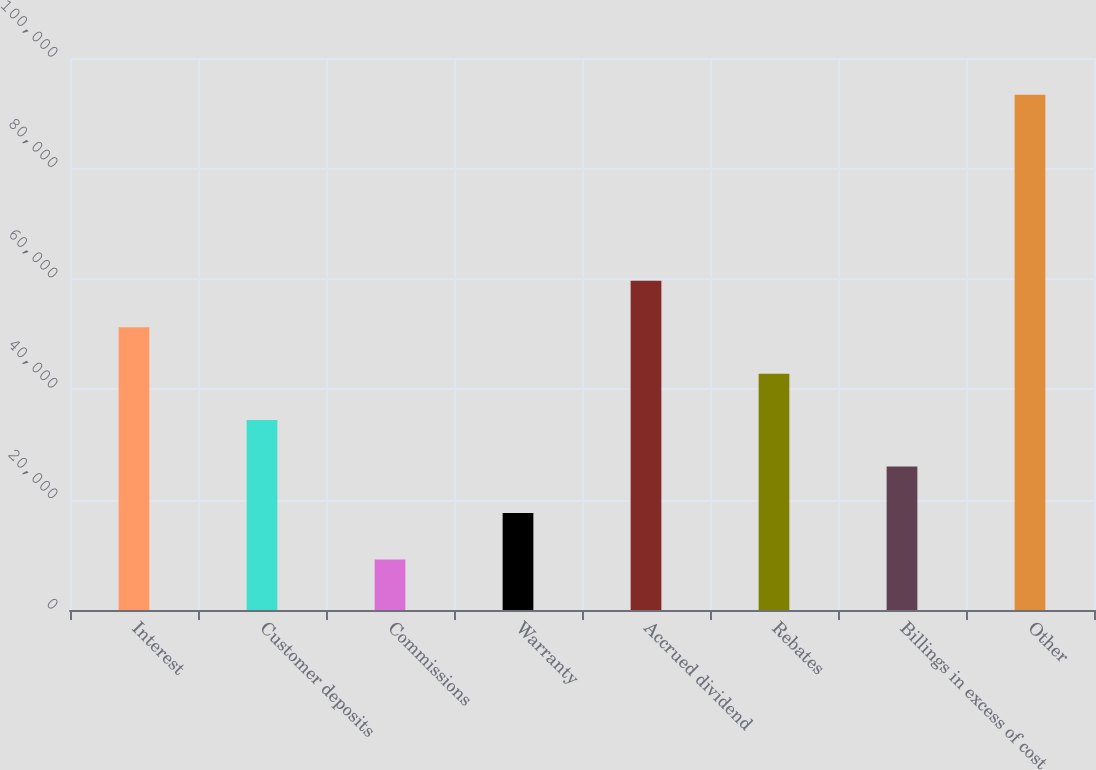<chart> <loc_0><loc_0><loc_500><loc_500><bar_chart><fcel>Interest<fcel>Customer deposits<fcel>Commissions<fcel>Warranty<fcel>Accrued dividend<fcel>Rebates<fcel>Billings in excess of cost<fcel>Other<nl><fcel>51235<fcel>34398.6<fcel>9144<fcel>17562.2<fcel>59653.2<fcel>42816.8<fcel>25980.4<fcel>93326<nl></chart> 